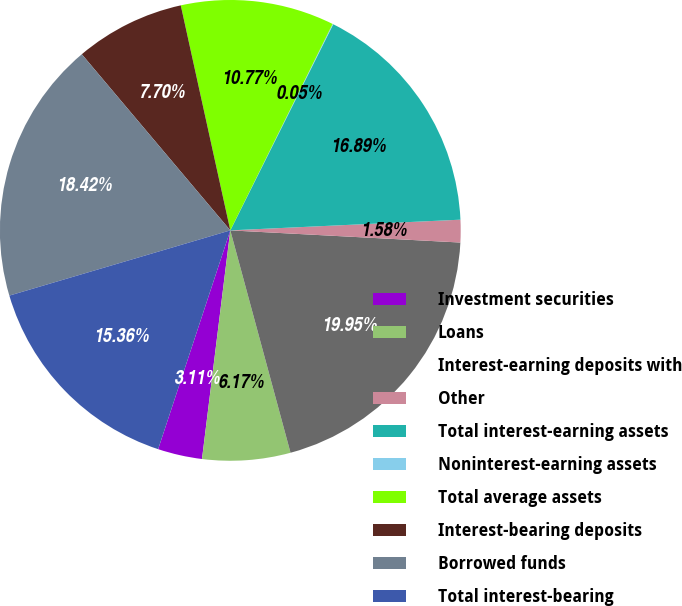Convert chart to OTSL. <chart><loc_0><loc_0><loc_500><loc_500><pie_chart><fcel>Investment securities<fcel>Loans<fcel>Interest-earning deposits with<fcel>Other<fcel>Total interest-earning assets<fcel>Noninterest-earning assets<fcel>Total average assets<fcel>Interest-bearing deposits<fcel>Borrowed funds<fcel>Total interest-bearing<nl><fcel>3.11%<fcel>6.17%<fcel>19.95%<fcel>1.58%<fcel>16.89%<fcel>0.05%<fcel>10.77%<fcel>7.7%<fcel>18.42%<fcel>15.36%<nl></chart> 